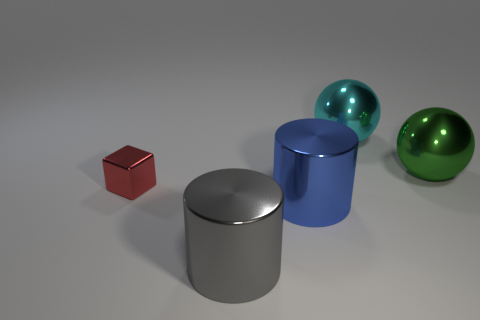Add 3 big shiny things. How many objects exist? 8 Subtract all spheres. How many objects are left? 3 Add 3 tiny shiny objects. How many tiny shiny objects are left? 4 Add 4 purple rubber spheres. How many purple rubber spheres exist? 4 Subtract 0 purple cubes. How many objects are left? 5 Subtract all red spheres. Subtract all large blue shiny things. How many objects are left? 4 